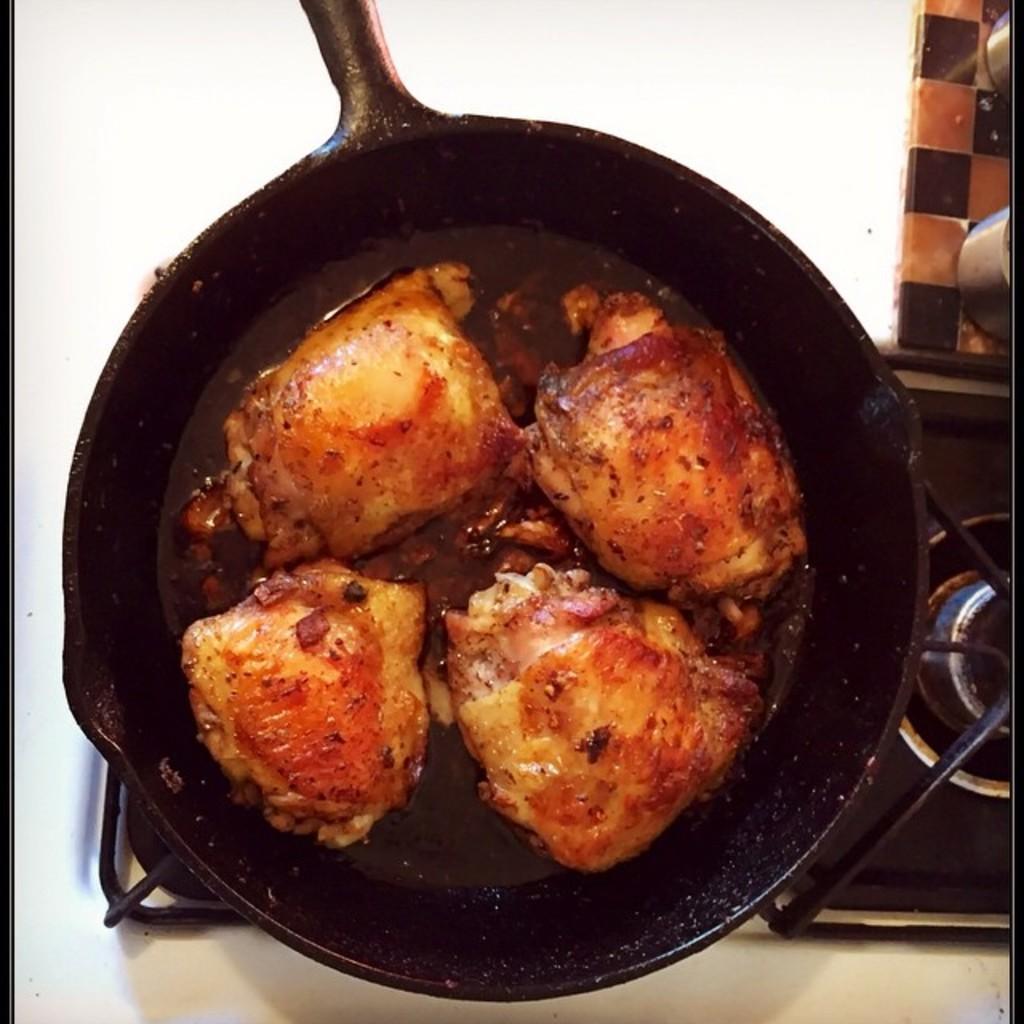Please provide a concise description of this image. In this image we can see the food item in the black vessel which is on the glass stove. We can also see the white surface. 